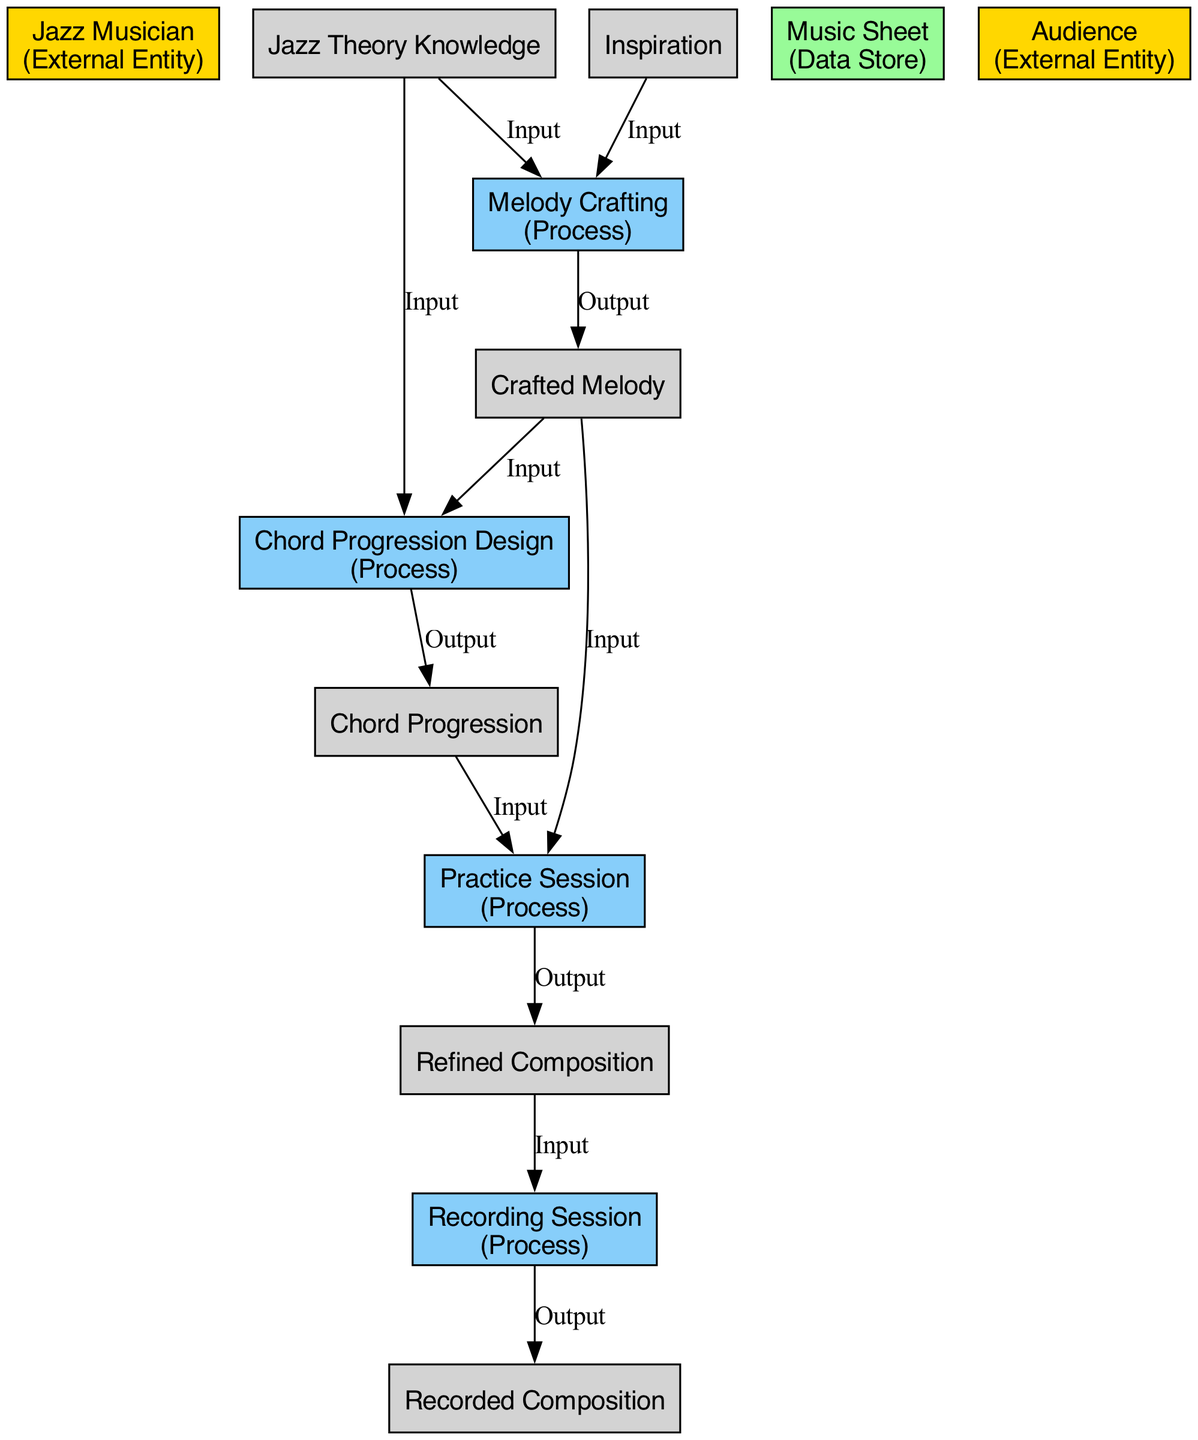What is the primary actor in the jazz composition process? The diagram identifies "Jazz Musician" as the primary actor, categorized as an "External Entity." This is evident from the label of the element that represents the musician's role in the diagram.
Answer: Jazz Musician How many processes are involved in the composition creation? By counting the nodes labeled as "Process" in the diagram, we find that there are four distinct processes represented: Melody Crafting, Chord Progression Design, Practice Session, and Recording Session.
Answer: Four What is the final output of the jazz composition creation process? Tracing the flow in the diagram, the final output is produced after the "Recording Session," which outputs the "Recorded Composition."
Answer: Recorded Composition Which process receives inputs from both "Crafted Melody" and "Chord Progression"? The process labeled "Practice Session" receives inputs from both "Crafted Melody" and "Chord Progression," as indicated by the arrows connecting these elements in the diagram.
Answer: Practice Session What data store is utilized during the composition process? The diagram lists "Music Sheet" as the data store used to hold the written parts of the composition. This is a dedicated storage node in the diagram for the musical elements.
Answer: Music Sheet What input is required for the "Chord Progression Design" process? The inputs required for the "Chord Progression Design" process are "Crafted Melody" and "Jazz Theory Knowledge," which are indicated in the connecting arrows towards this process in the diagram.
Answer: Crafted Melody, Jazz Theory Knowledge Which external entity represents the audience in the jazz composition process? The "Audience" is identified as the external entity that represents the listeners or consumers, as marked within the diagram itself.
Answer: Audience What is the output of the "Melody Crafting" process? According to the diagram, the output of the "Melody Crafting" process is the "Crafted Melody," which is directly linked as an output from this process.
Answer: Crafted Melody 